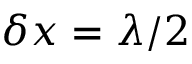Convert formula to latex. <formula><loc_0><loc_0><loc_500><loc_500>\delta x = \lambda / 2</formula> 